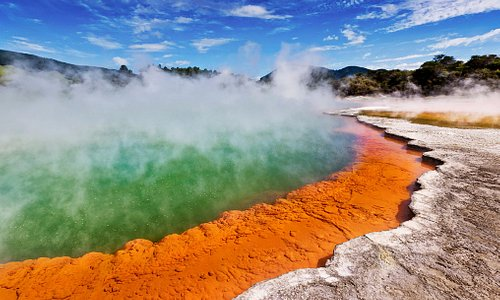How do tourists typically react to this landscape? Tourists are generally awestruck by the vibrant colors and dynamic landscape of Wai-O-Tapu. The unusual and sometimes otherworldly appearance of the geothermal features, coupled with informative trails and viewpoints, offer a memorable experience. Many visitors find it educational as well, as the park provides insights into the geological processes that shape our planet. The combination of natural beauty, scientific interest, and the physical vastness often leaves a lasting impression on those who visit. 